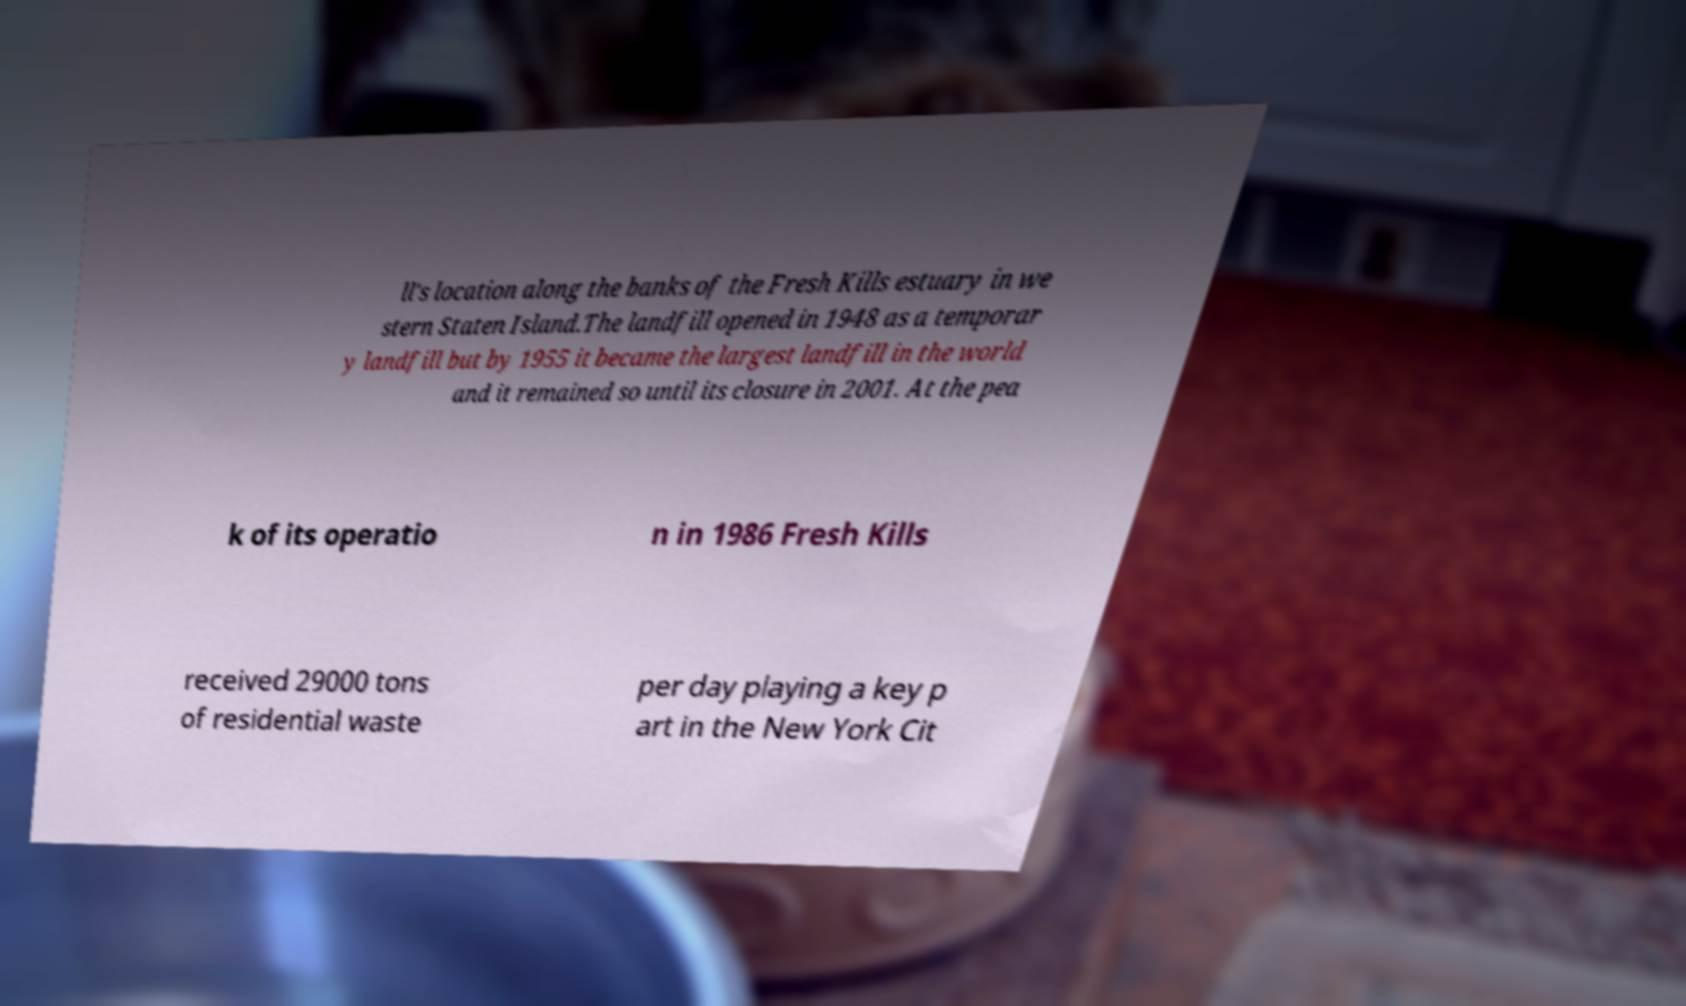Could you assist in decoding the text presented in this image and type it out clearly? ll's location along the banks of the Fresh Kills estuary in we stern Staten Island.The landfill opened in 1948 as a temporar y landfill but by 1955 it became the largest landfill in the world and it remained so until its closure in 2001. At the pea k of its operatio n in 1986 Fresh Kills received 29000 tons of residential waste per day playing a key p art in the New York Cit 